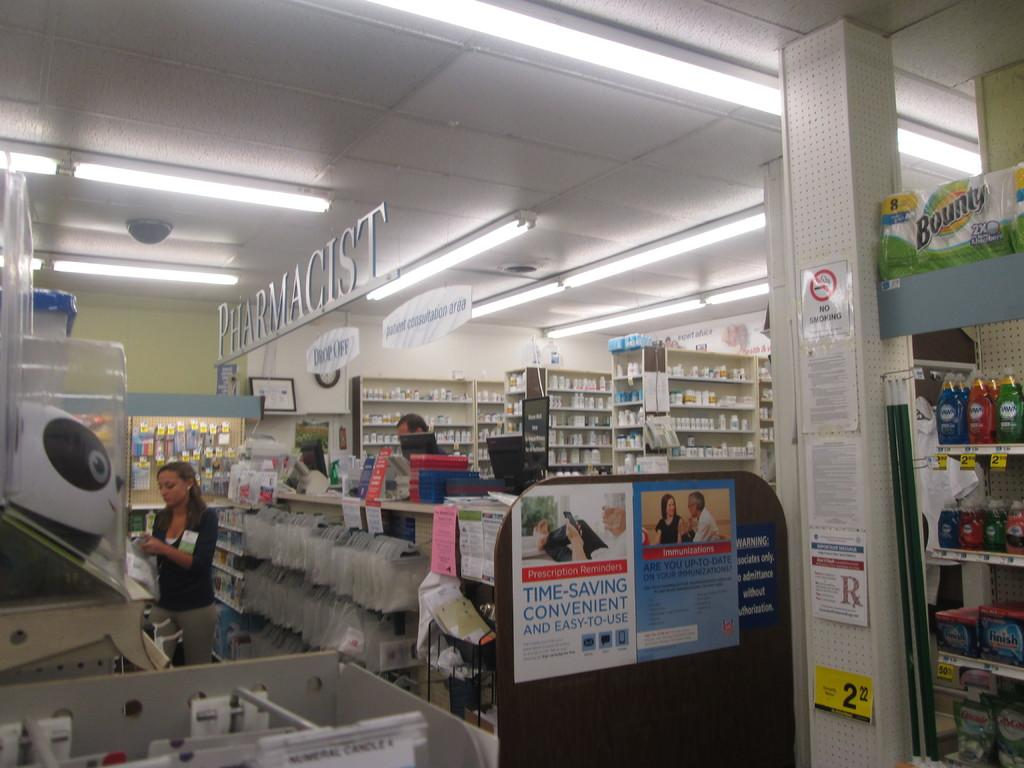<image>
Describe the image concisely. A sign at the pharmacy reads "time-saving convenient and easy to use" 